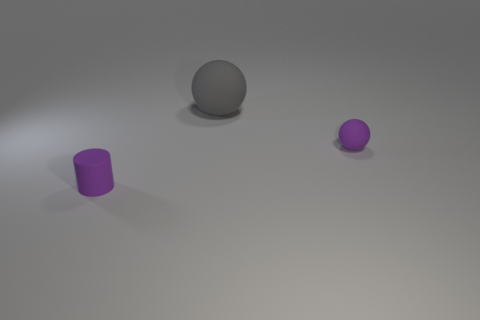Is there a red cube made of the same material as the tiny cylinder?
Your response must be concise. No. There is a purple rubber object left of the large sphere; are there any big gray matte objects that are in front of it?
Offer a very short reply. No. Does the matte object that is to the right of the gray object have the same size as the large gray rubber ball?
Ensure brevity in your answer.  No. The purple matte sphere has what size?
Provide a succinct answer. Small. Are there any small balls of the same color as the big rubber ball?
Give a very brief answer. No. How many small things are purple rubber objects or purple rubber cylinders?
Make the answer very short. 2. There is a object that is right of the tiny cylinder and on the left side of the purple rubber ball; what is its size?
Keep it short and to the point. Large. There is a gray object; what number of purple objects are on the right side of it?
Keep it short and to the point. 1. There is a rubber object that is right of the purple cylinder and on the left side of the tiny purple rubber ball; what shape is it?
Your response must be concise. Sphere. What material is the tiny thing that is the same color as the tiny cylinder?
Your answer should be very brief. Rubber. 